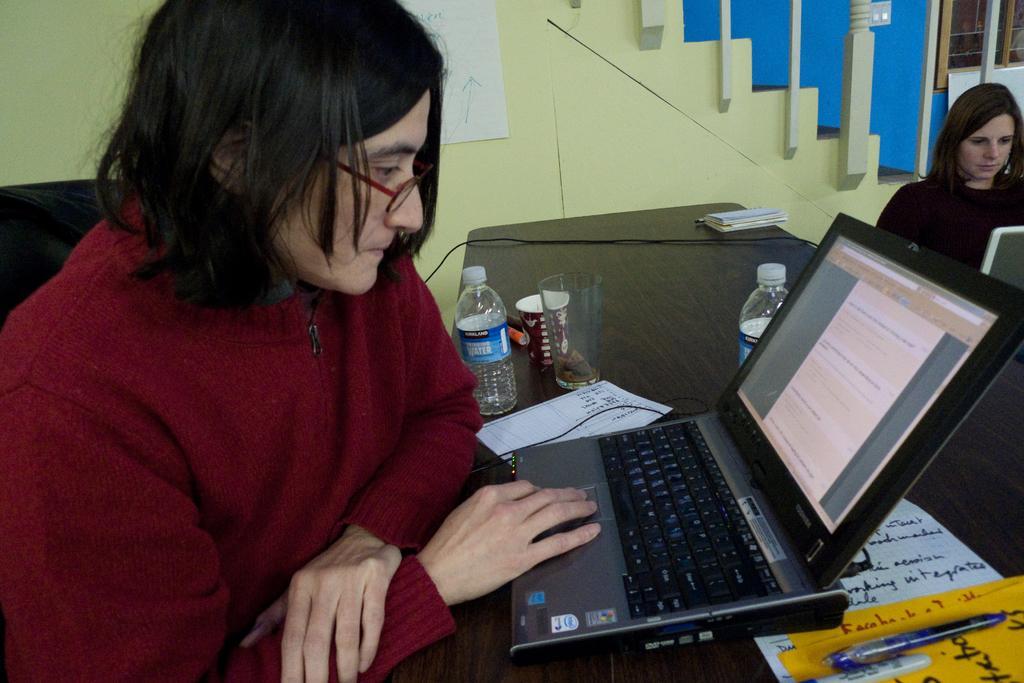How would you summarize this image in a sentence or two? On the left we can see a woman sitting on the chair and working on the laptop which is on the table and there are water bottles,glass,cup,books,papers,pens and cable on the table. On the right we can see a woman and a laptop. In the background we can see a paper on the wall,steps,switchboard on the wall and a window. 